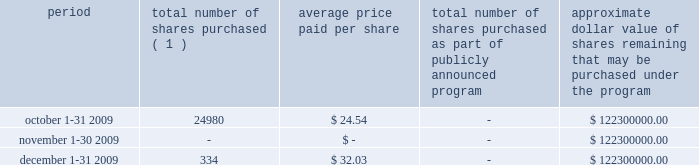We are required under the terms of our preferred stock to pay scheduled quarterly dividends , subject to legally available funds .
For so long as the preferred stock remains outstanding , ( 1 ) we will not declare , pay or set apart funds for the payment of any dividend or other distribution with respect to any junior stock or parity stock and ( 2 ) neither we , nor any of our subsidiaries , will , subject to certain exceptions , redeem , purchase or otherwise acquire for consideration junior stock or parity stock through a sinking fund or otherwise , in each case unless we have paid or set apart funds for the payment of all accumulated and unpaid dividends with respect to the shares of preferred stock and any parity stock for all preceding dividend periods .
Pursuant to this policy , we paid quarterly dividends of $ 0.265625 per share on our preferred stock on february 1 , 2009 , may 1 , 2009 , august 3 , 2009 and november 2 , 2009 and similar quarterly dividends during each quarter of 2008 .
The annual cash dividend declared and paid during the years ended december 31 , 2009 and 2008 were $ 10 million and $ 10 million , respectively .
On january 5 , 2010 , we declared a cash dividend of $ 0.265625 per share on our preferred stock amounting to $ 3 million and a cash dividend of $ 0.04 per share on our series a common stock amounting to $ 6 million .
Both cash dividends are for the period from november 2 , 2009 to january 31 , 2010 and were paid on february 1 , 2010 to holders of record as of january 15 , 2010 .
On february 1 , 2010 , we announced we would elect to redeem all of our outstanding preferred stock on february 22 , 2010 .
Holders of the preferred stock also have the right to convert their shares at any time prior to 5:00 p.m. , new york city time , on february 19 , 2010 , the business day immediately preceding the february 22 , 2010 redemption date .
Based on the number of outstanding shares as of december 31 , 2009 and considering the redemption of our preferred stock , cash dividends to be paid in 2010 are expected to result in annual dividend payments less than those paid in 2009 .
The amount available to us to pay cash dividends is restricted by our senior credit agreement .
Any decision to declare and pay dividends in the future will be made at the discretion of our board of directors and will depend on , among other things , our results of operations , cash requirements , financial condition , contractual restrictions and other factors that our board of directors may deem relevant .
Celanese purchases of its equity securities the table below sets forth information regarding repurchases of our series a common stock during the three months ended december 31 , 2009 : period total number of shares purchased ( 1 ) average price paid per share total number of shares purchased as part of publicly announced program approximate dollar value of shares remaining that may be purchased under the program .
( 1 ) relates to shares employees have elected to have withheld to cover their statutory minimum withholding requirements for personal income taxes related to the vesting of restricted stock units .
No shares were purchased during the three months ended december 31 , 2009 under our previously announced stock repurchase plan .
%%transmsg*** transmitting job : d70731 pcn : 033000000 ***%%pcmsg|33 |00012|yes|no|02/10/2010 05:41|0|0|page is valid , no graphics -- color : n| .
What os the growth rate in the average price of shares from october to december 2009? 
Computations: ((32.03 - 24.54) / 24.54)
Answer: 0.30522. 